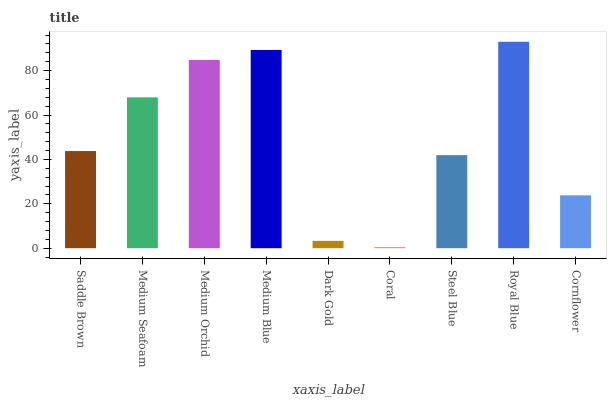Is Royal Blue the maximum?
Answer yes or no. Yes. Is Medium Seafoam the minimum?
Answer yes or no. No. Is Medium Seafoam the maximum?
Answer yes or no. No. Is Medium Seafoam greater than Saddle Brown?
Answer yes or no. Yes. Is Saddle Brown less than Medium Seafoam?
Answer yes or no. Yes. Is Saddle Brown greater than Medium Seafoam?
Answer yes or no. No. Is Medium Seafoam less than Saddle Brown?
Answer yes or no. No. Is Saddle Brown the high median?
Answer yes or no. Yes. Is Saddle Brown the low median?
Answer yes or no. Yes. Is Coral the high median?
Answer yes or no. No. Is Dark Gold the low median?
Answer yes or no. No. 